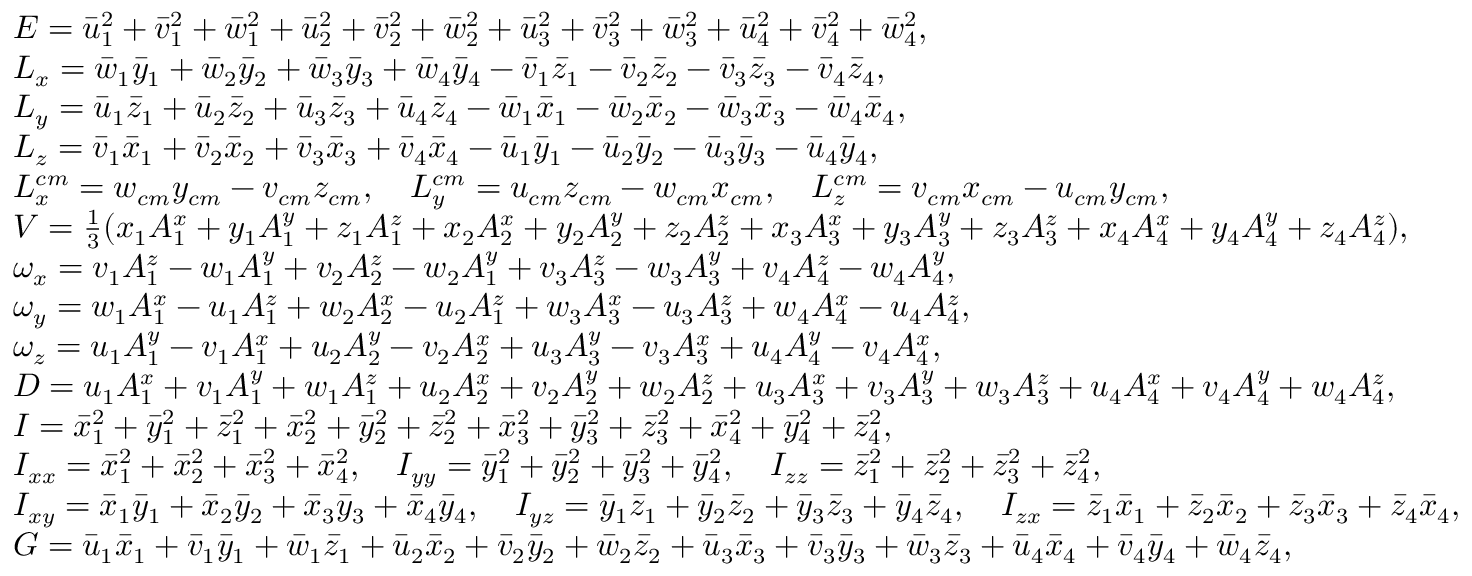<formula> <loc_0><loc_0><loc_500><loc_500>\begin{array} { r l } & { E = \ B a r { u } _ { 1 } ^ { 2 } + \ B a r { v } _ { 1 } ^ { 2 } + \ B a r { w } _ { 1 } ^ { 2 } + \ B a r { u } _ { 2 } ^ { 2 } + \ B a r { v } _ { 2 } ^ { 2 } + \ B a r { w } _ { 2 } ^ { 2 } + \ B a r { u } _ { 3 } ^ { 2 } + \ B a r { v } _ { 3 } ^ { 2 } + \ B a r { w } _ { 3 } ^ { 2 } + \ B a r { u } _ { 4 } ^ { 2 } + \ B a r { v } _ { 4 } ^ { 2 } + \ B a r { w } _ { 4 } ^ { 2 } , } \\ & { L _ { x } = \ B a r { w } _ { 1 } \ B a r { y } _ { 1 } + \ B a r { w } _ { 2 } \ B a r { y } _ { 2 } + \ B a r { w } _ { 3 } \ B a r { y } _ { 3 } + \ B a r { w } _ { 4 } \ B a r { y } _ { 4 } - \ B a r { v } _ { 1 } \ B a r { z } _ { 1 } - \ B a r { v } _ { 2 } \ B a r { z } _ { 2 } - \ B a r { v } _ { 3 } \ B a r { z } _ { 3 } - \ B a r { v } _ { 4 } \ B a r { z } _ { 4 } , } \\ & { L _ { y } = \ B a r { u } _ { 1 } \ B a r { z } _ { 1 } + \ B a r { u } _ { 2 } \ B a r { z } _ { 2 } + \ B a r { u } _ { 3 } \ B a r { z } _ { 3 } + \ B a r { u } _ { 4 } \ B a r { z } _ { 4 } - \ B a r { w } _ { 1 } \ B a r { x } _ { 1 } - \ B a r { w } _ { 2 } \ B a r { x } _ { 2 } - \ B a r { w } _ { 3 } \ B a r { x } _ { 3 } - \ B a r { w } _ { 4 } \ B a r { x } _ { 4 } , } \\ & { L _ { z } = \ B a r { v } _ { 1 } \ B a r { x } _ { 1 } + \ B a r { v } _ { 2 } \ B a r { x } _ { 2 } + \ B a r { v } _ { 3 } \ B a r { x } _ { 3 } + \ B a r { v } _ { 4 } \ B a r { x } _ { 4 } - \ B a r { u } _ { 1 } \ B a r { y } _ { 1 } - \ B a r { u } _ { 2 } \ B a r { y } _ { 2 } - \ B a r { u } _ { 3 } \ B a r { y } _ { 3 } - \ B a r { u } _ { 4 } \ B a r { y } _ { 4 } , } \\ & { L _ { x } ^ { c m } = w _ { c m } y _ { c m } - v _ { c m } z _ { c m } , \quad L _ { y } ^ { c m } = u _ { c m } z _ { c m } - w _ { c m } x _ { c m } , \quad L _ { z } ^ { c m } = v _ { c m } x _ { c m } - u _ { c m } y _ { c m } , } \\ & { V = \frac { 1 } { 3 } ( x _ { 1 } A _ { 1 } ^ { x } + y _ { 1 } A _ { 1 } ^ { y } + z _ { 1 } A _ { 1 } ^ { z } + x _ { 2 } A _ { 2 } ^ { x } + y _ { 2 } A _ { 2 } ^ { y } + z _ { 2 } A _ { 2 } ^ { z } + x _ { 3 } A _ { 3 } ^ { x } + y _ { 3 } A _ { 3 } ^ { y } + z _ { 3 } A _ { 3 } ^ { z } + x _ { 4 } A _ { 4 } ^ { x } + y _ { 4 } A _ { 4 } ^ { y } + z _ { 4 } A _ { 4 } ^ { z } ) , } \\ & { \omega _ { x } = v _ { 1 } A _ { 1 } ^ { z } - w _ { 1 } A _ { 1 } ^ { y } + v _ { 2 } A _ { 2 } ^ { z } - w _ { 2 } A _ { 1 } ^ { y } + v _ { 3 } A _ { 3 } ^ { z } - w _ { 3 } A _ { 3 } ^ { y } + v _ { 4 } A _ { 4 } ^ { z } - w _ { 4 } A _ { 4 } ^ { y } , } \\ & { \omega _ { y } = w _ { 1 } A _ { 1 } ^ { x } - u _ { 1 } A _ { 1 } ^ { z } + w _ { 2 } A _ { 2 } ^ { x } - u _ { 2 } A _ { 1 } ^ { z } + w _ { 3 } A _ { 3 } ^ { x } - u _ { 3 } A _ { 3 } ^ { z } + w _ { 4 } A _ { 4 } ^ { x } - u _ { 4 } A _ { 4 } ^ { z } , } \\ & { \omega _ { z } = u _ { 1 } A _ { 1 } ^ { y } - v _ { 1 } A _ { 1 } ^ { x } + u _ { 2 } A _ { 2 } ^ { y } - v _ { 2 } A _ { 2 } ^ { x } + u _ { 3 } A _ { 3 } ^ { y } - v _ { 3 } A _ { 3 } ^ { x } + u _ { 4 } A _ { 4 } ^ { y } - v _ { 4 } A _ { 4 } ^ { x } , } \\ & { D = u _ { 1 } A _ { 1 } ^ { x } + v _ { 1 } A _ { 1 } ^ { y } + w _ { 1 } A _ { 1 } ^ { z } + u _ { 2 } A _ { 2 } ^ { x } + v _ { 2 } A _ { 2 } ^ { y } + w _ { 2 } A _ { 2 } ^ { z } + u _ { 3 } A _ { 3 } ^ { x } + v _ { 3 } A _ { 3 } ^ { y } + w _ { 3 } A _ { 3 } ^ { z } + u _ { 4 } A _ { 4 } ^ { x } + v _ { 4 } A _ { 4 } ^ { y } + w _ { 4 } A _ { 4 } ^ { z } , } \\ & { I = \ B a r { x } _ { 1 } ^ { 2 } + \ B a r { y } _ { 1 } ^ { 2 } + \ B a r { z } _ { 1 } ^ { 2 } + \ B a r { x } _ { 2 } ^ { 2 } + \ B a r { y } _ { 2 } ^ { 2 } + \ B a r { z } _ { 2 } ^ { 2 } + \ B a r { x } _ { 3 } ^ { 2 } + \ B a r { y } _ { 3 } ^ { 2 } + \ B a r { z } _ { 3 } ^ { 2 } + \ B a r { x } _ { 4 } ^ { 2 } + \ B a r { y } _ { 4 } ^ { 2 } + \ B a r { z } _ { 4 } ^ { 2 } , } \\ & { I _ { x x } = \ B a r { x } _ { 1 } ^ { 2 } + \ B a r { x } _ { 2 } ^ { 2 } + \ B a r { x } _ { 3 } ^ { 2 } + \ B a r { x } _ { 4 } ^ { 2 } , \quad I _ { y y } = \ B a r { y } _ { 1 } ^ { 2 } + \ B a r { y } _ { 2 } ^ { 2 } + \ B a r { y } _ { 3 } ^ { 2 } + \ B a r { y } _ { 4 } ^ { 2 } , \quad I _ { z z } = \ B a r { z } _ { 1 } ^ { 2 } + \ B a r { z } _ { 2 } ^ { 2 } + \ B a r { z } _ { 3 } ^ { 2 } + \ B a r { z } _ { 4 } ^ { 2 } , } \\ & { I _ { x y } = \ B a r { x } _ { 1 } \ B a r { y } _ { 1 } + \ B a r { x } _ { 2 } \ B a r { y } _ { 2 } + \ B a r { x } _ { 3 } \ B a r { y } _ { 3 } + \ B a r { x } _ { 4 } \ B a r { y } _ { 4 } , \quad I _ { y z } = \ B a r { y } _ { 1 } \ B a r { z } _ { 1 } + \ B a r { y } _ { 2 } \ B a r { z } _ { 2 } + \ B a r { y } _ { 3 } \ B a r { z } _ { 3 } + \ B a r { y } _ { 4 } \ B a r { z } _ { 4 } , \quad I _ { z x } = \ B a r { z } _ { 1 } \ B a r { x } _ { 1 } + \ B a r { z } _ { 2 } \ B a r { x } _ { 2 } + \ B a r { z } _ { 3 } \ B a r { x } _ { 3 } + \ B a r { z } _ { 4 } \ B a r { x } _ { 4 } , } \\ & { G = \ B a r { u } _ { 1 } \ B a r { x } _ { 1 } + \ B a r { v } _ { 1 } \ B a r { y } _ { 1 } + \ B a r { w } _ { 1 } \ B a r { z } _ { 1 } + \ B a r { u } _ { 2 } \ B a r { x } _ { 2 } + \ B a r { v } _ { 2 } \ B a r { y } _ { 2 } + \ B a r { w } _ { 2 } \ B a r { z } _ { 2 } + \ B a r { u } _ { 3 } \ B a r { x } _ { 3 } + \ B a r { v } _ { 3 } \ B a r { y } _ { 3 } + \ B a r { w } _ { 3 } \ B a r { z } _ { 3 } + \ B a r { u } _ { 4 } \ B a r { x } _ { 4 } + \ B a r { v } _ { 4 } \ B a r { y } _ { 4 } + \ B a r { w } _ { 4 } \ B a r { z } _ { 4 } , } \end{array}</formula> 